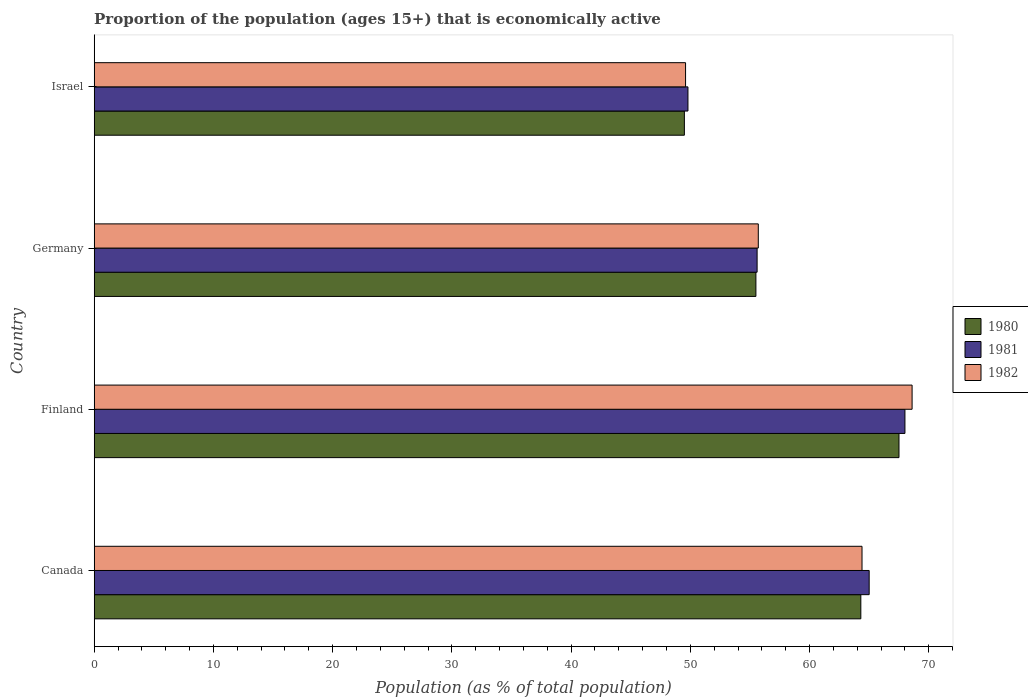Are the number of bars per tick equal to the number of legend labels?
Provide a succinct answer. Yes. Are the number of bars on each tick of the Y-axis equal?
Provide a short and direct response. Yes. How many bars are there on the 3rd tick from the top?
Make the answer very short. 3. How many bars are there on the 3rd tick from the bottom?
Your response must be concise. 3. In how many cases, is the number of bars for a given country not equal to the number of legend labels?
Offer a very short reply. 0. What is the proportion of the population that is economically active in 1981 in Germany?
Your answer should be compact. 55.6. Across all countries, what is the maximum proportion of the population that is economically active in 1981?
Your answer should be compact. 68. Across all countries, what is the minimum proportion of the population that is economically active in 1980?
Your answer should be compact. 49.5. What is the total proportion of the population that is economically active in 1981 in the graph?
Offer a terse response. 238.4. What is the difference between the proportion of the population that is economically active in 1982 in Finland and that in Israel?
Ensure brevity in your answer.  19. What is the difference between the proportion of the population that is economically active in 1980 in Israel and the proportion of the population that is economically active in 1982 in Germany?
Your answer should be compact. -6.2. What is the average proportion of the population that is economically active in 1980 per country?
Make the answer very short. 59.2. What is the difference between the proportion of the population that is economically active in 1980 and proportion of the population that is economically active in 1981 in Finland?
Give a very brief answer. -0.5. What is the ratio of the proportion of the population that is economically active in 1982 in Finland to that in Germany?
Your response must be concise. 1.23. Is the proportion of the population that is economically active in 1981 in Canada less than that in Germany?
Ensure brevity in your answer.  No. Is the difference between the proportion of the population that is economically active in 1980 in Canada and Germany greater than the difference between the proportion of the population that is economically active in 1981 in Canada and Germany?
Give a very brief answer. No. What is the difference between the highest and the second highest proportion of the population that is economically active in 1982?
Offer a very short reply. 4.2. What is the difference between the highest and the lowest proportion of the population that is economically active in 1982?
Keep it short and to the point. 19. Is the sum of the proportion of the population that is economically active in 1981 in Finland and Israel greater than the maximum proportion of the population that is economically active in 1982 across all countries?
Keep it short and to the point. Yes. What does the 1st bar from the top in Finland represents?
Offer a very short reply. 1982. Is it the case that in every country, the sum of the proportion of the population that is economically active in 1981 and proportion of the population that is economically active in 1982 is greater than the proportion of the population that is economically active in 1980?
Provide a succinct answer. Yes. How many bars are there?
Keep it short and to the point. 12. Are the values on the major ticks of X-axis written in scientific E-notation?
Provide a succinct answer. No. Where does the legend appear in the graph?
Your answer should be very brief. Center right. How are the legend labels stacked?
Give a very brief answer. Vertical. What is the title of the graph?
Ensure brevity in your answer.  Proportion of the population (ages 15+) that is economically active. Does "1984" appear as one of the legend labels in the graph?
Your response must be concise. No. What is the label or title of the X-axis?
Give a very brief answer. Population (as % of total population). What is the Population (as % of total population) of 1980 in Canada?
Give a very brief answer. 64.3. What is the Population (as % of total population) of 1982 in Canada?
Ensure brevity in your answer.  64.4. What is the Population (as % of total population) of 1980 in Finland?
Offer a very short reply. 67.5. What is the Population (as % of total population) of 1982 in Finland?
Your answer should be compact. 68.6. What is the Population (as % of total population) in 1980 in Germany?
Your answer should be very brief. 55.5. What is the Population (as % of total population) in 1981 in Germany?
Give a very brief answer. 55.6. What is the Population (as % of total population) in 1982 in Germany?
Ensure brevity in your answer.  55.7. What is the Population (as % of total population) of 1980 in Israel?
Your answer should be compact. 49.5. What is the Population (as % of total population) of 1981 in Israel?
Give a very brief answer. 49.8. What is the Population (as % of total population) in 1982 in Israel?
Give a very brief answer. 49.6. Across all countries, what is the maximum Population (as % of total population) of 1980?
Offer a very short reply. 67.5. Across all countries, what is the maximum Population (as % of total population) in 1981?
Your response must be concise. 68. Across all countries, what is the maximum Population (as % of total population) in 1982?
Provide a short and direct response. 68.6. Across all countries, what is the minimum Population (as % of total population) in 1980?
Offer a very short reply. 49.5. Across all countries, what is the minimum Population (as % of total population) of 1981?
Your answer should be very brief. 49.8. Across all countries, what is the minimum Population (as % of total population) of 1982?
Make the answer very short. 49.6. What is the total Population (as % of total population) in 1980 in the graph?
Your response must be concise. 236.8. What is the total Population (as % of total population) of 1981 in the graph?
Provide a succinct answer. 238.4. What is the total Population (as % of total population) of 1982 in the graph?
Your answer should be very brief. 238.3. What is the difference between the Population (as % of total population) in 1980 in Canada and that in Finland?
Provide a short and direct response. -3.2. What is the difference between the Population (as % of total population) of 1980 in Canada and that in Germany?
Your answer should be compact. 8.8. What is the difference between the Population (as % of total population) of 1980 in Canada and that in Israel?
Your answer should be very brief. 14.8. What is the difference between the Population (as % of total population) in 1982 in Canada and that in Israel?
Provide a short and direct response. 14.8. What is the difference between the Population (as % of total population) of 1980 in Finland and that in Germany?
Provide a short and direct response. 12. What is the difference between the Population (as % of total population) of 1982 in Finland and that in Germany?
Keep it short and to the point. 12.9. What is the difference between the Population (as % of total population) of 1980 in Finland and that in Israel?
Give a very brief answer. 18. What is the difference between the Population (as % of total population) in 1981 in Finland and that in Israel?
Your response must be concise. 18.2. What is the difference between the Population (as % of total population) in 1981 in Germany and that in Israel?
Provide a short and direct response. 5.8. What is the difference between the Population (as % of total population) of 1982 in Germany and that in Israel?
Provide a succinct answer. 6.1. What is the difference between the Population (as % of total population) in 1980 in Canada and the Population (as % of total population) in 1981 in Finland?
Keep it short and to the point. -3.7. What is the difference between the Population (as % of total population) of 1981 in Canada and the Population (as % of total population) of 1982 in Finland?
Your answer should be compact. -3.6. What is the difference between the Population (as % of total population) of 1980 in Canada and the Population (as % of total population) of 1982 in Germany?
Ensure brevity in your answer.  8.6. What is the difference between the Population (as % of total population) of 1980 in Canada and the Population (as % of total population) of 1982 in Israel?
Provide a short and direct response. 14.7. What is the difference between the Population (as % of total population) in 1981 in Canada and the Population (as % of total population) in 1982 in Israel?
Make the answer very short. 15.4. What is the difference between the Population (as % of total population) of 1980 in Finland and the Population (as % of total population) of 1982 in Germany?
Make the answer very short. 11.8. What is the difference between the Population (as % of total population) of 1980 in Finland and the Population (as % of total population) of 1981 in Israel?
Offer a terse response. 17.7. What is the difference between the Population (as % of total population) in 1980 in Finland and the Population (as % of total population) in 1982 in Israel?
Your answer should be compact. 17.9. What is the difference between the Population (as % of total population) of 1980 in Germany and the Population (as % of total population) of 1982 in Israel?
Offer a terse response. 5.9. What is the average Population (as % of total population) of 1980 per country?
Provide a succinct answer. 59.2. What is the average Population (as % of total population) in 1981 per country?
Your answer should be compact. 59.6. What is the average Population (as % of total population) of 1982 per country?
Give a very brief answer. 59.58. What is the difference between the Population (as % of total population) in 1981 and Population (as % of total population) in 1982 in Finland?
Offer a terse response. -0.6. What is the difference between the Population (as % of total population) of 1981 and Population (as % of total population) of 1982 in Germany?
Provide a short and direct response. -0.1. What is the ratio of the Population (as % of total population) in 1980 in Canada to that in Finland?
Offer a terse response. 0.95. What is the ratio of the Population (as % of total population) in 1981 in Canada to that in Finland?
Offer a terse response. 0.96. What is the ratio of the Population (as % of total population) in 1982 in Canada to that in Finland?
Your answer should be compact. 0.94. What is the ratio of the Population (as % of total population) in 1980 in Canada to that in Germany?
Your answer should be compact. 1.16. What is the ratio of the Population (as % of total population) in 1981 in Canada to that in Germany?
Your response must be concise. 1.17. What is the ratio of the Population (as % of total population) of 1982 in Canada to that in Germany?
Ensure brevity in your answer.  1.16. What is the ratio of the Population (as % of total population) in 1980 in Canada to that in Israel?
Provide a succinct answer. 1.3. What is the ratio of the Population (as % of total population) of 1981 in Canada to that in Israel?
Provide a succinct answer. 1.31. What is the ratio of the Population (as % of total population) of 1982 in Canada to that in Israel?
Your response must be concise. 1.3. What is the ratio of the Population (as % of total population) of 1980 in Finland to that in Germany?
Provide a short and direct response. 1.22. What is the ratio of the Population (as % of total population) of 1981 in Finland to that in Germany?
Offer a terse response. 1.22. What is the ratio of the Population (as % of total population) in 1982 in Finland to that in Germany?
Your response must be concise. 1.23. What is the ratio of the Population (as % of total population) of 1980 in Finland to that in Israel?
Your answer should be very brief. 1.36. What is the ratio of the Population (as % of total population) of 1981 in Finland to that in Israel?
Give a very brief answer. 1.37. What is the ratio of the Population (as % of total population) in 1982 in Finland to that in Israel?
Keep it short and to the point. 1.38. What is the ratio of the Population (as % of total population) in 1980 in Germany to that in Israel?
Give a very brief answer. 1.12. What is the ratio of the Population (as % of total population) in 1981 in Germany to that in Israel?
Provide a short and direct response. 1.12. What is the ratio of the Population (as % of total population) of 1982 in Germany to that in Israel?
Ensure brevity in your answer.  1.12. What is the difference between the highest and the second highest Population (as % of total population) of 1981?
Provide a short and direct response. 3. What is the difference between the highest and the lowest Population (as % of total population) of 1981?
Offer a terse response. 18.2. What is the difference between the highest and the lowest Population (as % of total population) in 1982?
Give a very brief answer. 19. 